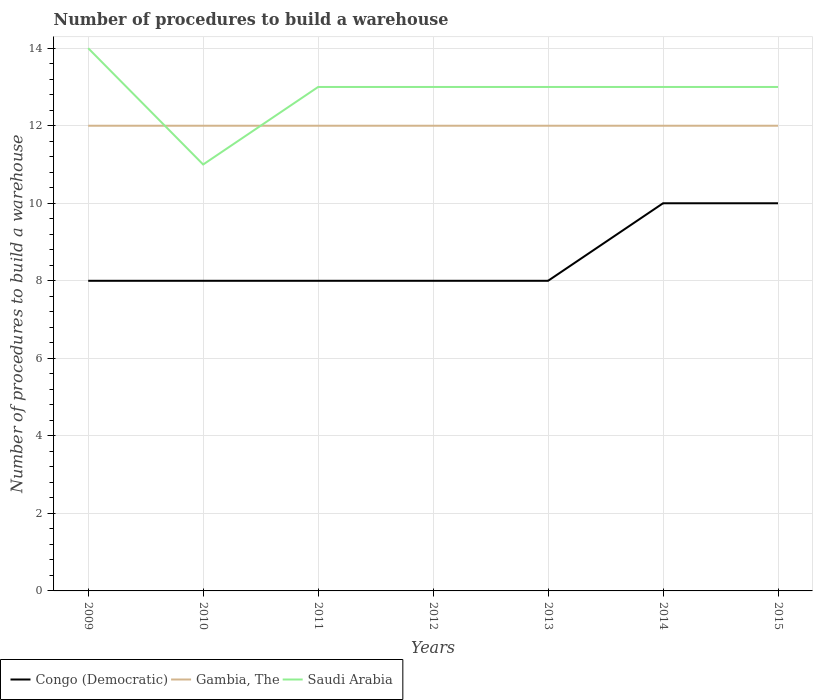How many different coloured lines are there?
Offer a terse response. 3. Does the line corresponding to Gambia, The intersect with the line corresponding to Congo (Democratic)?
Offer a terse response. No. Is the number of lines equal to the number of legend labels?
Offer a terse response. Yes. Across all years, what is the maximum number of procedures to build a warehouse in in Saudi Arabia?
Keep it short and to the point. 11. In which year was the number of procedures to build a warehouse in in Saudi Arabia maximum?
Provide a succinct answer. 2010. What is the total number of procedures to build a warehouse in in Congo (Democratic) in the graph?
Your answer should be very brief. -2. What is the difference between the highest and the second highest number of procedures to build a warehouse in in Congo (Democratic)?
Your answer should be compact. 2. What is the difference between the highest and the lowest number of procedures to build a warehouse in in Saudi Arabia?
Your answer should be compact. 6. Is the number of procedures to build a warehouse in in Congo (Democratic) strictly greater than the number of procedures to build a warehouse in in Gambia, The over the years?
Your answer should be very brief. Yes. How many lines are there?
Give a very brief answer. 3. How many years are there in the graph?
Keep it short and to the point. 7. What is the difference between two consecutive major ticks on the Y-axis?
Offer a very short reply. 2. Are the values on the major ticks of Y-axis written in scientific E-notation?
Your response must be concise. No. Does the graph contain grids?
Provide a short and direct response. Yes. How many legend labels are there?
Offer a terse response. 3. How are the legend labels stacked?
Provide a succinct answer. Horizontal. What is the title of the graph?
Your response must be concise. Number of procedures to build a warehouse. Does "Seychelles" appear as one of the legend labels in the graph?
Offer a very short reply. No. What is the label or title of the Y-axis?
Ensure brevity in your answer.  Number of procedures to build a warehouse. What is the Number of procedures to build a warehouse in Congo (Democratic) in 2009?
Give a very brief answer. 8. What is the Number of procedures to build a warehouse in Congo (Democratic) in 2010?
Your answer should be compact. 8. What is the Number of procedures to build a warehouse of Congo (Democratic) in 2011?
Your response must be concise. 8. What is the Number of procedures to build a warehouse in Gambia, The in 2011?
Keep it short and to the point. 12. What is the Number of procedures to build a warehouse in Saudi Arabia in 2012?
Offer a very short reply. 13. What is the Number of procedures to build a warehouse in Congo (Democratic) in 2013?
Offer a terse response. 8. What is the Number of procedures to build a warehouse of Saudi Arabia in 2013?
Make the answer very short. 13. What is the Number of procedures to build a warehouse in Congo (Democratic) in 2014?
Make the answer very short. 10. What is the Number of procedures to build a warehouse in Gambia, The in 2014?
Provide a short and direct response. 12. What is the Number of procedures to build a warehouse in Congo (Democratic) in 2015?
Keep it short and to the point. 10. What is the Number of procedures to build a warehouse of Gambia, The in 2015?
Your response must be concise. 12. What is the Number of procedures to build a warehouse in Saudi Arabia in 2015?
Your answer should be compact. 13. Across all years, what is the maximum Number of procedures to build a warehouse of Gambia, The?
Keep it short and to the point. 12. Across all years, what is the minimum Number of procedures to build a warehouse of Congo (Democratic)?
Your answer should be compact. 8. Across all years, what is the minimum Number of procedures to build a warehouse in Saudi Arabia?
Provide a short and direct response. 11. What is the total Number of procedures to build a warehouse of Congo (Democratic) in the graph?
Your response must be concise. 60. What is the total Number of procedures to build a warehouse of Gambia, The in the graph?
Ensure brevity in your answer.  84. What is the total Number of procedures to build a warehouse of Saudi Arabia in the graph?
Offer a very short reply. 90. What is the difference between the Number of procedures to build a warehouse of Gambia, The in 2009 and that in 2010?
Provide a succinct answer. 0. What is the difference between the Number of procedures to build a warehouse in Gambia, The in 2009 and that in 2011?
Your answer should be very brief. 0. What is the difference between the Number of procedures to build a warehouse of Congo (Democratic) in 2009 and that in 2012?
Your response must be concise. 0. What is the difference between the Number of procedures to build a warehouse in Saudi Arabia in 2009 and that in 2012?
Provide a succinct answer. 1. What is the difference between the Number of procedures to build a warehouse of Congo (Democratic) in 2009 and that in 2013?
Ensure brevity in your answer.  0. What is the difference between the Number of procedures to build a warehouse in Gambia, The in 2009 and that in 2013?
Ensure brevity in your answer.  0. What is the difference between the Number of procedures to build a warehouse in Saudi Arabia in 2009 and that in 2013?
Provide a short and direct response. 1. What is the difference between the Number of procedures to build a warehouse in Congo (Democratic) in 2009 and that in 2014?
Offer a terse response. -2. What is the difference between the Number of procedures to build a warehouse of Saudi Arabia in 2009 and that in 2014?
Offer a terse response. 1. What is the difference between the Number of procedures to build a warehouse in Gambia, The in 2009 and that in 2015?
Keep it short and to the point. 0. What is the difference between the Number of procedures to build a warehouse in Saudi Arabia in 2009 and that in 2015?
Your response must be concise. 1. What is the difference between the Number of procedures to build a warehouse of Saudi Arabia in 2010 and that in 2011?
Give a very brief answer. -2. What is the difference between the Number of procedures to build a warehouse in Congo (Democratic) in 2010 and that in 2012?
Offer a terse response. 0. What is the difference between the Number of procedures to build a warehouse of Gambia, The in 2010 and that in 2012?
Ensure brevity in your answer.  0. What is the difference between the Number of procedures to build a warehouse of Gambia, The in 2010 and that in 2013?
Give a very brief answer. 0. What is the difference between the Number of procedures to build a warehouse of Gambia, The in 2010 and that in 2014?
Your answer should be very brief. 0. What is the difference between the Number of procedures to build a warehouse of Saudi Arabia in 2010 and that in 2014?
Provide a short and direct response. -2. What is the difference between the Number of procedures to build a warehouse of Congo (Democratic) in 2010 and that in 2015?
Offer a terse response. -2. What is the difference between the Number of procedures to build a warehouse of Saudi Arabia in 2010 and that in 2015?
Your answer should be compact. -2. What is the difference between the Number of procedures to build a warehouse of Congo (Democratic) in 2011 and that in 2013?
Provide a succinct answer. 0. What is the difference between the Number of procedures to build a warehouse in Gambia, The in 2011 and that in 2013?
Your response must be concise. 0. What is the difference between the Number of procedures to build a warehouse of Congo (Democratic) in 2011 and that in 2014?
Provide a short and direct response. -2. What is the difference between the Number of procedures to build a warehouse of Gambia, The in 2011 and that in 2015?
Your response must be concise. 0. What is the difference between the Number of procedures to build a warehouse of Saudi Arabia in 2011 and that in 2015?
Make the answer very short. 0. What is the difference between the Number of procedures to build a warehouse of Congo (Democratic) in 2012 and that in 2013?
Keep it short and to the point. 0. What is the difference between the Number of procedures to build a warehouse of Gambia, The in 2012 and that in 2013?
Provide a short and direct response. 0. What is the difference between the Number of procedures to build a warehouse of Saudi Arabia in 2012 and that in 2013?
Provide a short and direct response. 0. What is the difference between the Number of procedures to build a warehouse in Congo (Democratic) in 2012 and that in 2014?
Keep it short and to the point. -2. What is the difference between the Number of procedures to build a warehouse of Congo (Democratic) in 2012 and that in 2015?
Give a very brief answer. -2. What is the difference between the Number of procedures to build a warehouse in Gambia, The in 2012 and that in 2015?
Make the answer very short. 0. What is the difference between the Number of procedures to build a warehouse of Congo (Democratic) in 2013 and that in 2014?
Provide a succinct answer. -2. What is the difference between the Number of procedures to build a warehouse of Gambia, The in 2013 and that in 2014?
Keep it short and to the point. 0. What is the difference between the Number of procedures to build a warehouse of Gambia, The in 2013 and that in 2015?
Your response must be concise. 0. What is the difference between the Number of procedures to build a warehouse in Gambia, The in 2014 and that in 2015?
Make the answer very short. 0. What is the difference between the Number of procedures to build a warehouse in Congo (Democratic) in 2009 and the Number of procedures to build a warehouse in Saudi Arabia in 2010?
Ensure brevity in your answer.  -3. What is the difference between the Number of procedures to build a warehouse in Congo (Democratic) in 2009 and the Number of procedures to build a warehouse in Gambia, The in 2011?
Offer a very short reply. -4. What is the difference between the Number of procedures to build a warehouse in Congo (Democratic) in 2009 and the Number of procedures to build a warehouse in Saudi Arabia in 2011?
Offer a terse response. -5. What is the difference between the Number of procedures to build a warehouse in Gambia, The in 2009 and the Number of procedures to build a warehouse in Saudi Arabia in 2011?
Your response must be concise. -1. What is the difference between the Number of procedures to build a warehouse of Congo (Democratic) in 2009 and the Number of procedures to build a warehouse of Gambia, The in 2013?
Provide a succinct answer. -4. What is the difference between the Number of procedures to build a warehouse in Gambia, The in 2009 and the Number of procedures to build a warehouse in Saudi Arabia in 2013?
Your answer should be very brief. -1. What is the difference between the Number of procedures to build a warehouse in Congo (Democratic) in 2009 and the Number of procedures to build a warehouse in Saudi Arabia in 2015?
Make the answer very short. -5. What is the difference between the Number of procedures to build a warehouse of Gambia, The in 2009 and the Number of procedures to build a warehouse of Saudi Arabia in 2015?
Your response must be concise. -1. What is the difference between the Number of procedures to build a warehouse in Gambia, The in 2010 and the Number of procedures to build a warehouse in Saudi Arabia in 2011?
Provide a succinct answer. -1. What is the difference between the Number of procedures to build a warehouse in Congo (Democratic) in 2010 and the Number of procedures to build a warehouse in Gambia, The in 2012?
Keep it short and to the point. -4. What is the difference between the Number of procedures to build a warehouse of Congo (Democratic) in 2010 and the Number of procedures to build a warehouse of Saudi Arabia in 2012?
Give a very brief answer. -5. What is the difference between the Number of procedures to build a warehouse in Congo (Democratic) in 2010 and the Number of procedures to build a warehouse in Saudi Arabia in 2013?
Offer a very short reply. -5. What is the difference between the Number of procedures to build a warehouse in Gambia, The in 2010 and the Number of procedures to build a warehouse in Saudi Arabia in 2013?
Give a very brief answer. -1. What is the difference between the Number of procedures to build a warehouse in Gambia, The in 2010 and the Number of procedures to build a warehouse in Saudi Arabia in 2014?
Keep it short and to the point. -1. What is the difference between the Number of procedures to build a warehouse of Congo (Democratic) in 2010 and the Number of procedures to build a warehouse of Saudi Arabia in 2015?
Provide a short and direct response. -5. What is the difference between the Number of procedures to build a warehouse of Gambia, The in 2010 and the Number of procedures to build a warehouse of Saudi Arabia in 2015?
Provide a short and direct response. -1. What is the difference between the Number of procedures to build a warehouse in Congo (Democratic) in 2011 and the Number of procedures to build a warehouse in Saudi Arabia in 2012?
Your response must be concise. -5. What is the difference between the Number of procedures to build a warehouse of Gambia, The in 2011 and the Number of procedures to build a warehouse of Saudi Arabia in 2012?
Provide a short and direct response. -1. What is the difference between the Number of procedures to build a warehouse in Congo (Democratic) in 2011 and the Number of procedures to build a warehouse in Gambia, The in 2013?
Provide a succinct answer. -4. What is the difference between the Number of procedures to build a warehouse of Gambia, The in 2011 and the Number of procedures to build a warehouse of Saudi Arabia in 2013?
Provide a short and direct response. -1. What is the difference between the Number of procedures to build a warehouse in Congo (Democratic) in 2011 and the Number of procedures to build a warehouse in Gambia, The in 2014?
Keep it short and to the point. -4. What is the difference between the Number of procedures to build a warehouse in Congo (Democratic) in 2011 and the Number of procedures to build a warehouse in Saudi Arabia in 2014?
Make the answer very short. -5. What is the difference between the Number of procedures to build a warehouse in Gambia, The in 2011 and the Number of procedures to build a warehouse in Saudi Arabia in 2014?
Provide a short and direct response. -1. What is the difference between the Number of procedures to build a warehouse in Congo (Democratic) in 2011 and the Number of procedures to build a warehouse in Gambia, The in 2015?
Provide a succinct answer. -4. What is the difference between the Number of procedures to build a warehouse of Congo (Democratic) in 2012 and the Number of procedures to build a warehouse of Saudi Arabia in 2013?
Your response must be concise. -5. What is the difference between the Number of procedures to build a warehouse of Congo (Democratic) in 2012 and the Number of procedures to build a warehouse of Gambia, The in 2014?
Your response must be concise. -4. What is the difference between the Number of procedures to build a warehouse of Gambia, The in 2012 and the Number of procedures to build a warehouse of Saudi Arabia in 2014?
Provide a short and direct response. -1. What is the difference between the Number of procedures to build a warehouse in Congo (Democratic) in 2012 and the Number of procedures to build a warehouse in Saudi Arabia in 2015?
Offer a terse response. -5. What is the difference between the Number of procedures to build a warehouse in Congo (Democratic) in 2013 and the Number of procedures to build a warehouse in Saudi Arabia in 2014?
Offer a very short reply. -5. What is the difference between the Number of procedures to build a warehouse in Gambia, The in 2013 and the Number of procedures to build a warehouse in Saudi Arabia in 2014?
Your response must be concise. -1. What is the difference between the Number of procedures to build a warehouse of Congo (Democratic) in 2013 and the Number of procedures to build a warehouse of Saudi Arabia in 2015?
Give a very brief answer. -5. What is the difference between the Number of procedures to build a warehouse of Gambia, The in 2013 and the Number of procedures to build a warehouse of Saudi Arabia in 2015?
Offer a very short reply. -1. What is the difference between the Number of procedures to build a warehouse in Congo (Democratic) in 2014 and the Number of procedures to build a warehouse in Gambia, The in 2015?
Your answer should be compact. -2. What is the difference between the Number of procedures to build a warehouse of Congo (Democratic) in 2014 and the Number of procedures to build a warehouse of Saudi Arabia in 2015?
Provide a succinct answer. -3. What is the difference between the Number of procedures to build a warehouse in Gambia, The in 2014 and the Number of procedures to build a warehouse in Saudi Arabia in 2015?
Ensure brevity in your answer.  -1. What is the average Number of procedures to build a warehouse in Congo (Democratic) per year?
Offer a terse response. 8.57. What is the average Number of procedures to build a warehouse in Saudi Arabia per year?
Offer a very short reply. 12.86. In the year 2010, what is the difference between the Number of procedures to build a warehouse of Congo (Democratic) and Number of procedures to build a warehouse of Gambia, The?
Make the answer very short. -4. In the year 2011, what is the difference between the Number of procedures to build a warehouse in Gambia, The and Number of procedures to build a warehouse in Saudi Arabia?
Your answer should be compact. -1. In the year 2012, what is the difference between the Number of procedures to build a warehouse of Congo (Democratic) and Number of procedures to build a warehouse of Gambia, The?
Provide a succinct answer. -4. In the year 2012, what is the difference between the Number of procedures to build a warehouse in Congo (Democratic) and Number of procedures to build a warehouse in Saudi Arabia?
Provide a succinct answer. -5. In the year 2012, what is the difference between the Number of procedures to build a warehouse in Gambia, The and Number of procedures to build a warehouse in Saudi Arabia?
Your response must be concise. -1. In the year 2013, what is the difference between the Number of procedures to build a warehouse in Congo (Democratic) and Number of procedures to build a warehouse in Gambia, The?
Offer a very short reply. -4. In the year 2013, what is the difference between the Number of procedures to build a warehouse of Gambia, The and Number of procedures to build a warehouse of Saudi Arabia?
Keep it short and to the point. -1. In the year 2014, what is the difference between the Number of procedures to build a warehouse in Congo (Democratic) and Number of procedures to build a warehouse in Gambia, The?
Provide a short and direct response. -2. In the year 2014, what is the difference between the Number of procedures to build a warehouse in Gambia, The and Number of procedures to build a warehouse in Saudi Arabia?
Give a very brief answer. -1. In the year 2015, what is the difference between the Number of procedures to build a warehouse of Congo (Democratic) and Number of procedures to build a warehouse of Gambia, The?
Your answer should be compact. -2. In the year 2015, what is the difference between the Number of procedures to build a warehouse in Gambia, The and Number of procedures to build a warehouse in Saudi Arabia?
Your answer should be very brief. -1. What is the ratio of the Number of procedures to build a warehouse of Saudi Arabia in 2009 to that in 2010?
Provide a short and direct response. 1.27. What is the ratio of the Number of procedures to build a warehouse in Congo (Democratic) in 2009 to that in 2011?
Give a very brief answer. 1. What is the ratio of the Number of procedures to build a warehouse of Saudi Arabia in 2009 to that in 2011?
Ensure brevity in your answer.  1.08. What is the ratio of the Number of procedures to build a warehouse in Congo (Democratic) in 2009 to that in 2012?
Offer a terse response. 1. What is the ratio of the Number of procedures to build a warehouse in Gambia, The in 2009 to that in 2012?
Provide a succinct answer. 1. What is the ratio of the Number of procedures to build a warehouse in Congo (Democratic) in 2009 to that in 2013?
Provide a succinct answer. 1. What is the ratio of the Number of procedures to build a warehouse of Gambia, The in 2009 to that in 2014?
Your answer should be compact. 1. What is the ratio of the Number of procedures to build a warehouse of Saudi Arabia in 2009 to that in 2014?
Your answer should be compact. 1.08. What is the ratio of the Number of procedures to build a warehouse of Gambia, The in 2009 to that in 2015?
Your answer should be very brief. 1. What is the ratio of the Number of procedures to build a warehouse of Congo (Democratic) in 2010 to that in 2011?
Offer a terse response. 1. What is the ratio of the Number of procedures to build a warehouse of Saudi Arabia in 2010 to that in 2011?
Provide a succinct answer. 0.85. What is the ratio of the Number of procedures to build a warehouse of Gambia, The in 2010 to that in 2012?
Offer a very short reply. 1. What is the ratio of the Number of procedures to build a warehouse of Saudi Arabia in 2010 to that in 2012?
Your response must be concise. 0.85. What is the ratio of the Number of procedures to build a warehouse of Congo (Democratic) in 2010 to that in 2013?
Give a very brief answer. 1. What is the ratio of the Number of procedures to build a warehouse in Gambia, The in 2010 to that in 2013?
Offer a terse response. 1. What is the ratio of the Number of procedures to build a warehouse of Saudi Arabia in 2010 to that in 2013?
Your answer should be very brief. 0.85. What is the ratio of the Number of procedures to build a warehouse in Congo (Democratic) in 2010 to that in 2014?
Give a very brief answer. 0.8. What is the ratio of the Number of procedures to build a warehouse of Saudi Arabia in 2010 to that in 2014?
Offer a terse response. 0.85. What is the ratio of the Number of procedures to build a warehouse of Saudi Arabia in 2010 to that in 2015?
Offer a terse response. 0.85. What is the ratio of the Number of procedures to build a warehouse in Congo (Democratic) in 2011 to that in 2012?
Your answer should be very brief. 1. What is the ratio of the Number of procedures to build a warehouse in Saudi Arabia in 2011 to that in 2012?
Offer a terse response. 1. What is the ratio of the Number of procedures to build a warehouse of Gambia, The in 2011 to that in 2013?
Provide a succinct answer. 1. What is the ratio of the Number of procedures to build a warehouse of Saudi Arabia in 2011 to that in 2014?
Provide a short and direct response. 1. What is the ratio of the Number of procedures to build a warehouse of Gambia, The in 2011 to that in 2015?
Your answer should be very brief. 1. What is the ratio of the Number of procedures to build a warehouse in Saudi Arabia in 2011 to that in 2015?
Ensure brevity in your answer.  1. What is the ratio of the Number of procedures to build a warehouse in Gambia, The in 2012 to that in 2013?
Make the answer very short. 1. What is the ratio of the Number of procedures to build a warehouse in Gambia, The in 2012 to that in 2014?
Ensure brevity in your answer.  1. What is the ratio of the Number of procedures to build a warehouse of Saudi Arabia in 2012 to that in 2014?
Provide a succinct answer. 1. What is the ratio of the Number of procedures to build a warehouse of Congo (Democratic) in 2012 to that in 2015?
Ensure brevity in your answer.  0.8. What is the ratio of the Number of procedures to build a warehouse of Gambia, The in 2012 to that in 2015?
Your response must be concise. 1. What is the ratio of the Number of procedures to build a warehouse in Congo (Democratic) in 2013 to that in 2014?
Offer a terse response. 0.8. What is the ratio of the Number of procedures to build a warehouse in Saudi Arabia in 2013 to that in 2014?
Ensure brevity in your answer.  1. What is the ratio of the Number of procedures to build a warehouse in Congo (Democratic) in 2013 to that in 2015?
Make the answer very short. 0.8. What is the ratio of the Number of procedures to build a warehouse in Congo (Democratic) in 2014 to that in 2015?
Make the answer very short. 1. What is the difference between the highest and the second highest Number of procedures to build a warehouse in Gambia, The?
Offer a very short reply. 0. What is the difference between the highest and the second highest Number of procedures to build a warehouse of Saudi Arabia?
Your answer should be compact. 1. What is the difference between the highest and the lowest Number of procedures to build a warehouse in Congo (Democratic)?
Make the answer very short. 2. What is the difference between the highest and the lowest Number of procedures to build a warehouse of Saudi Arabia?
Offer a terse response. 3. 